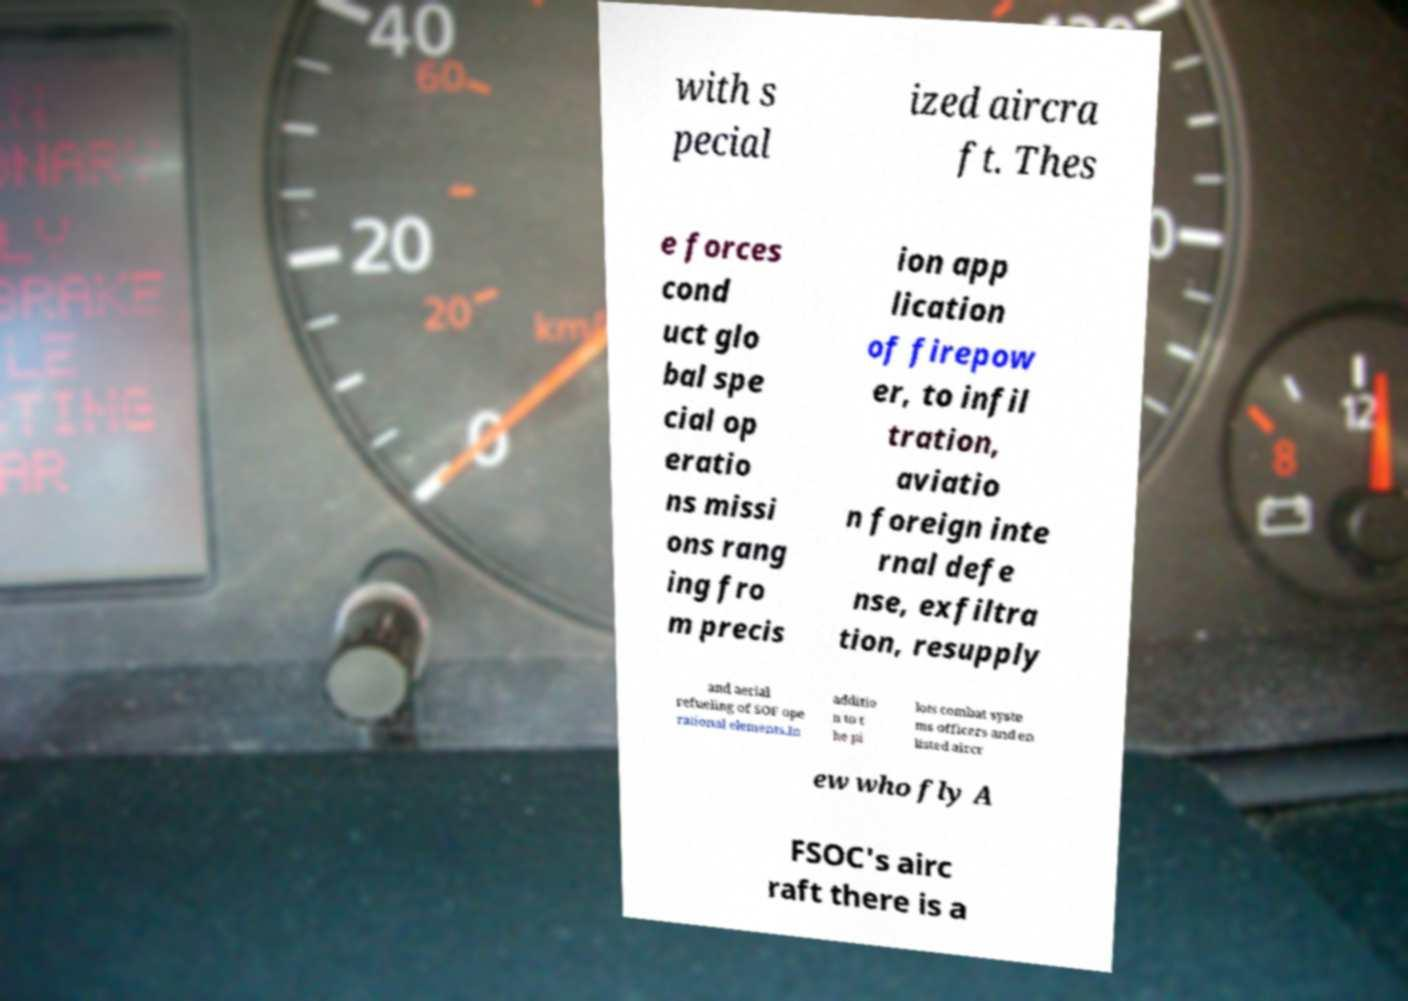Please read and relay the text visible in this image. What does it say? with s pecial ized aircra ft. Thes e forces cond uct glo bal spe cial op eratio ns missi ons rang ing fro m precis ion app lication of firepow er, to infil tration, aviatio n foreign inte rnal defe nse, exfiltra tion, resupply and aerial refueling of SOF ope rational elements.In additio n to t he pi lots combat syste ms officers and en listed aircr ew who fly A FSOC's airc raft there is a 